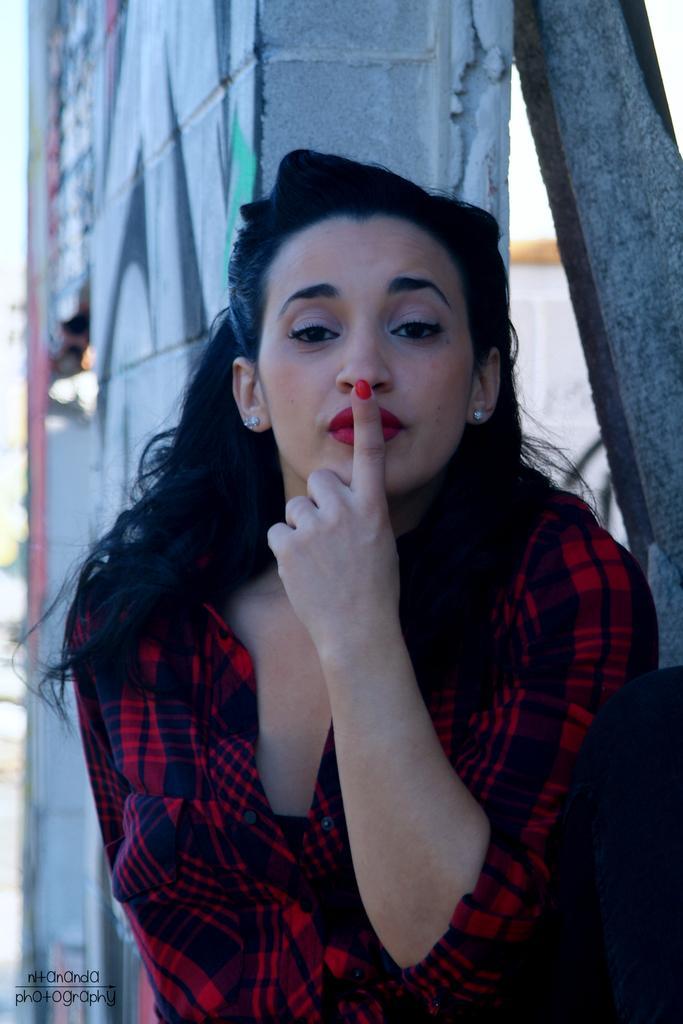In one or two sentences, can you explain what this image depicts? In the image there is a woman in red shirt keeping finger on her lip, behind her its a wall. 